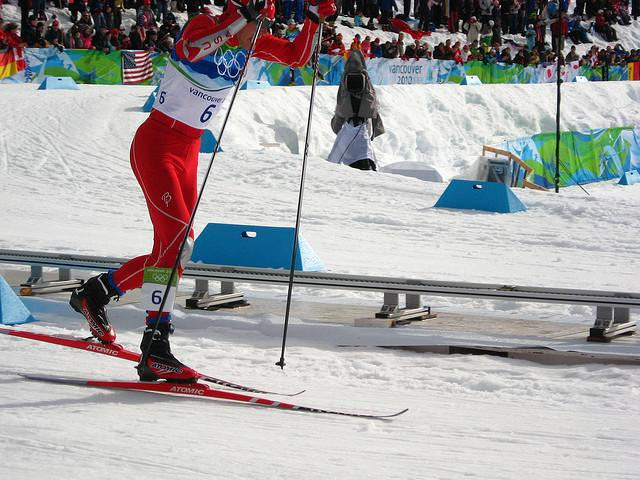What level of event is this? olympics 